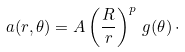Convert formula to latex. <formula><loc_0><loc_0><loc_500><loc_500>a ( r , \theta ) = A \left ( \frac { R } { r } \right ) ^ { p } \, g ( \theta ) \, \cdot</formula> 